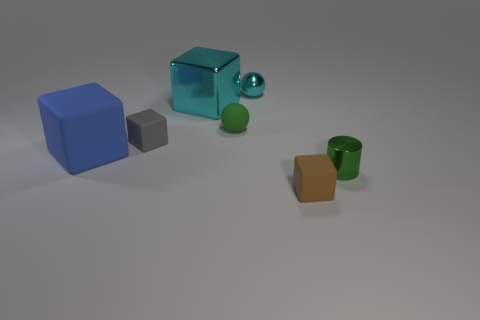Are there fewer blue matte cubes than small blue rubber balls?
Give a very brief answer. No. What number of other things are the same color as the big shiny object?
Offer a very short reply. 1. Is the material of the small thing that is behind the big cyan object the same as the large cyan block?
Give a very brief answer. Yes. What material is the green thing that is behind the green cylinder?
Ensure brevity in your answer.  Rubber. There is a cube in front of the tiny shiny object in front of the blue rubber cube; how big is it?
Your answer should be very brief. Small. Is there a large blue cylinder made of the same material as the small gray object?
Keep it short and to the point. No. What is the shape of the small rubber object that is on the right side of the ball behind the large cube behind the big blue object?
Your answer should be compact. Cube. There is a small metallic thing that is behind the tiny matte sphere; is its color the same as the block that is behind the green ball?
Provide a short and direct response. Yes. There is a tiny cyan sphere; are there any objects in front of it?
Your response must be concise. Yes. What number of small cyan metallic objects are the same shape as the small brown matte thing?
Offer a terse response. 0. 